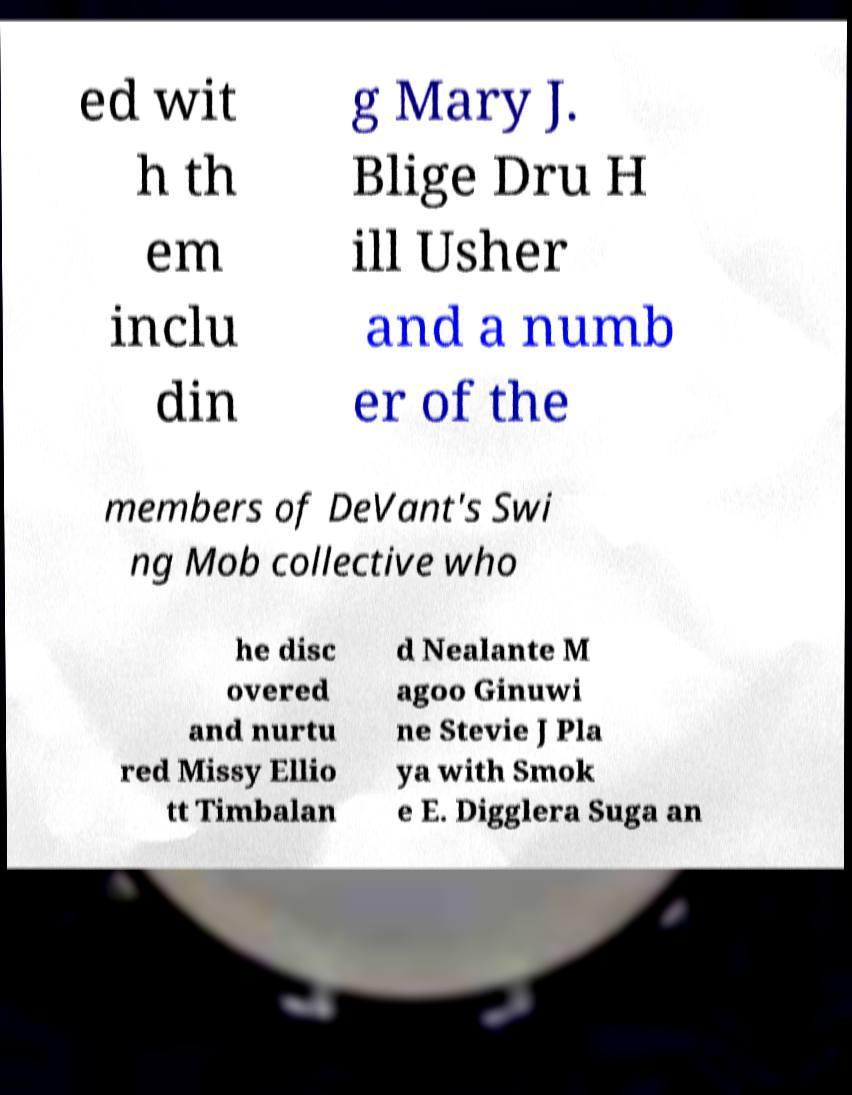There's text embedded in this image that I need extracted. Can you transcribe it verbatim? ed wit h th em inclu din g Mary J. Blige Dru H ill Usher and a numb er of the members of DeVant's Swi ng Mob collective who he disc overed and nurtu red Missy Ellio tt Timbalan d Nealante M agoo Ginuwi ne Stevie J Pla ya with Smok e E. Digglera Suga an 